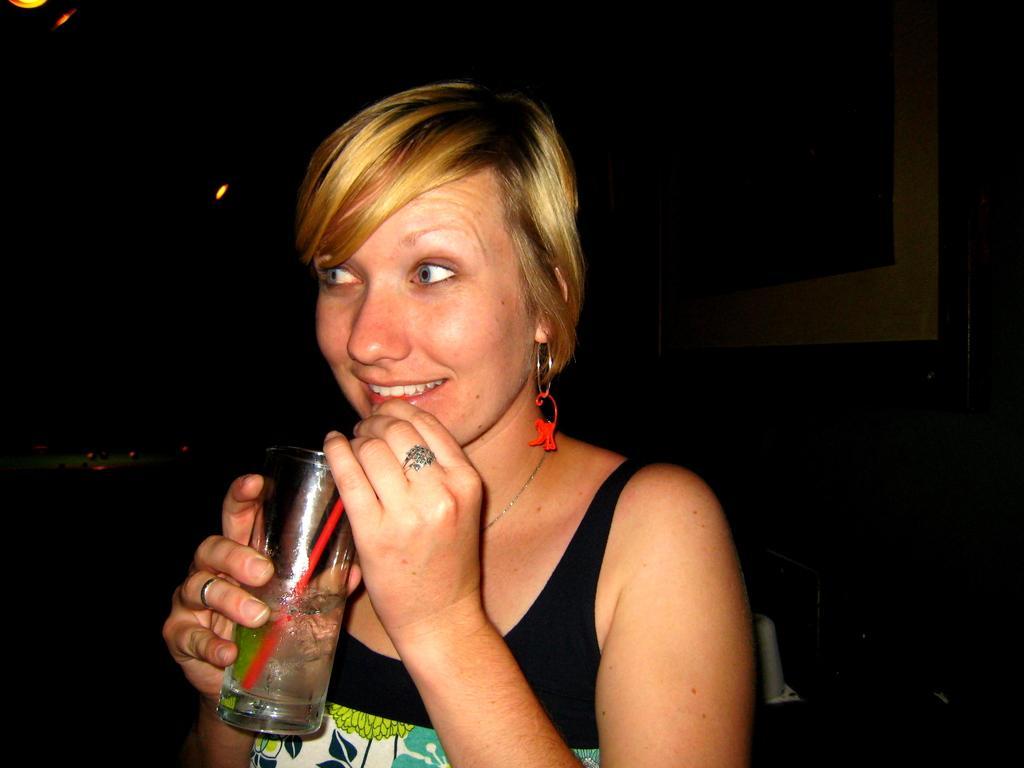Could you give a brief overview of what you see in this image? In this picture we can see a woman is holding a glass of drink and a straw in the front, there is a dark background. 